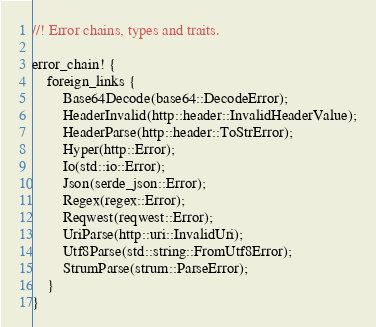Convert code to text. <code><loc_0><loc_0><loc_500><loc_500><_Rust_>//! Error chains, types and traits.

error_chain! {
    foreign_links {
        Base64Decode(base64::DecodeError);
        HeaderInvalid(http::header::InvalidHeaderValue);
        HeaderParse(http::header::ToStrError);
        Hyper(http::Error);
        Io(std::io::Error);
        Json(serde_json::Error);
        Regex(regex::Error);
        Reqwest(reqwest::Error);
        UriParse(http::uri::InvalidUri);
        Utf8Parse(std::string::FromUtf8Error);
        StrumParse(strum::ParseError);
    }
}
</code> 